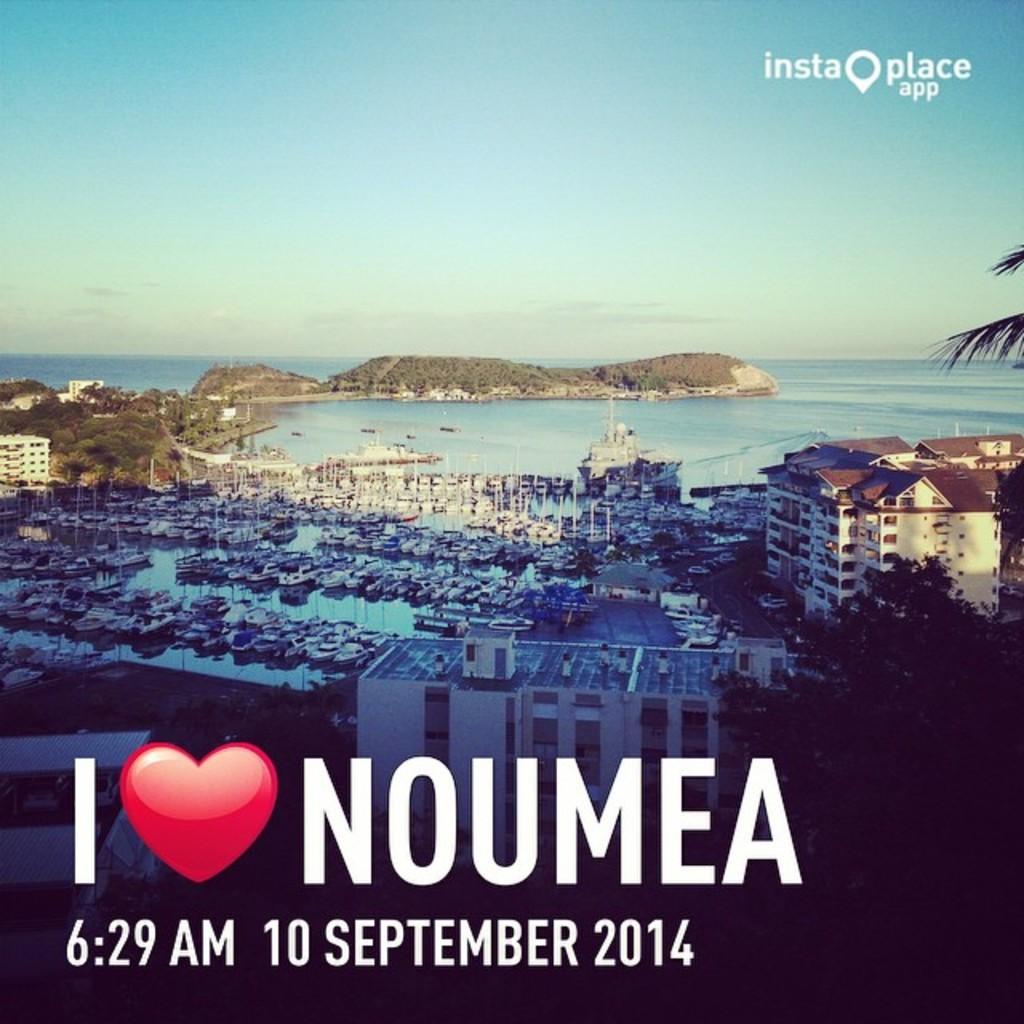What city is loved in this poster?
Give a very brief answer. Noumea. What time is on this poster?
Make the answer very short. 6:29 am. 